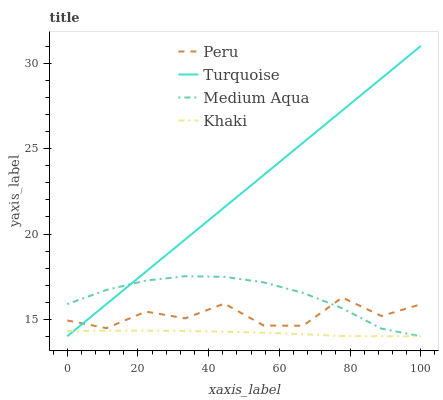Does Khaki have the minimum area under the curve?
Answer yes or no. Yes. Does Turquoise have the maximum area under the curve?
Answer yes or no. Yes. Does Medium Aqua have the minimum area under the curve?
Answer yes or no. No. Does Medium Aqua have the maximum area under the curve?
Answer yes or no. No. Is Turquoise the smoothest?
Answer yes or no. Yes. Is Peru the roughest?
Answer yes or no. Yes. Is Khaki the smoothest?
Answer yes or no. No. Is Khaki the roughest?
Answer yes or no. No. Does Turquoise have the lowest value?
Answer yes or no. Yes. Does Peru have the lowest value?
Answer yes or no. No. Does Turquoise have the highest value?
Answer yes or no. Yes. Does Medium Aqua have the highest value?
Answer yes or no. No. Is Khaki less than Peru?
Answer yes or no. Yes. Is Peru greater than Khaki?
Answer yes or no. Yes. Does Khaki intersect Turquoise?
Answer yes or no. Yes. Is Khaki less than Turquoise?
Answer yes or no. No. Is Khaki greater than Turquoise?
Answer yes or no. No. Does Khaki intersect Peru?
Answer yes or no. No. 